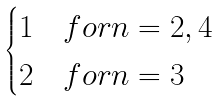Convert formula to latex. <formula><loc_0><loc_0><loc_500><loc_500>\begin{cases} 1 & f o r n = 2 , 4 \\ 2 & f o r n = 3 \end{cases}</formula> 